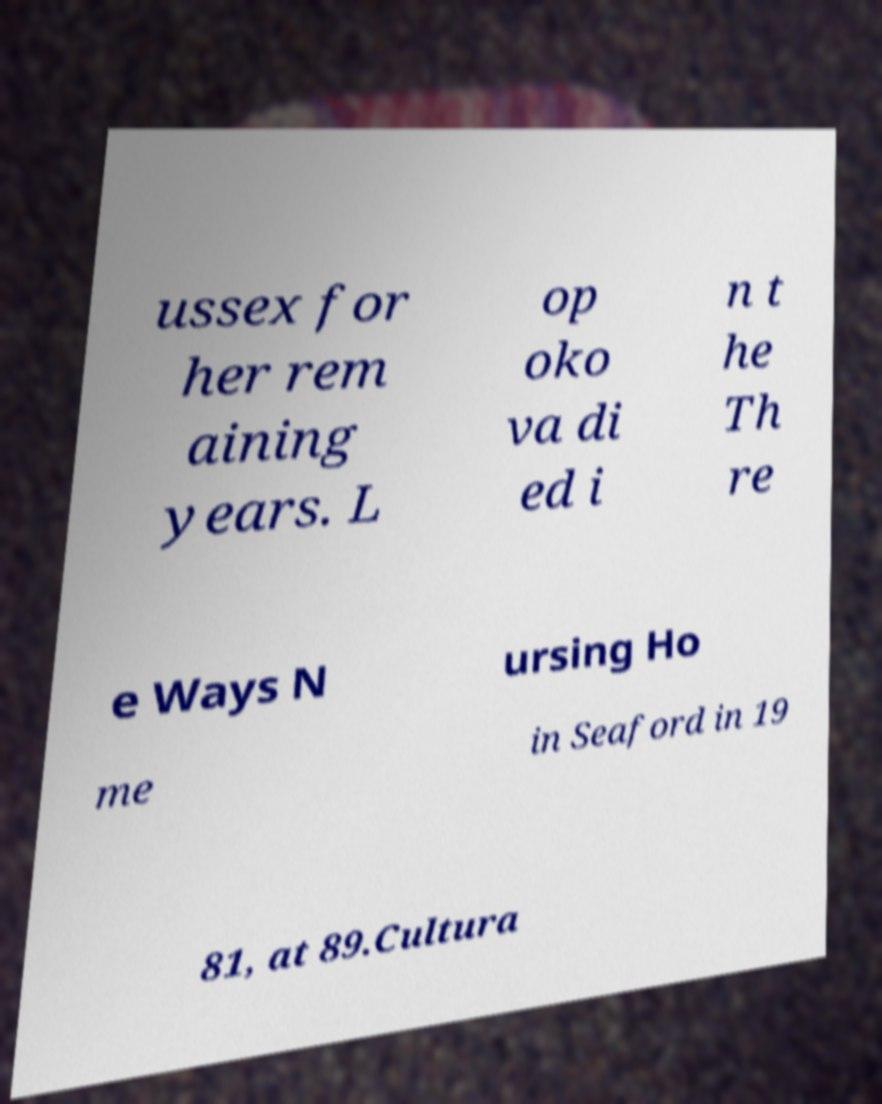Can you read and provide the text displayed in the image?This photo seems to have some interesting text. Can you extract and type it out for me? ussex for her rem aining years. L op oko va di ed i n t he Th re e Ways N ursing Ho me in Seaford in 19 81, at 89.Cultura 